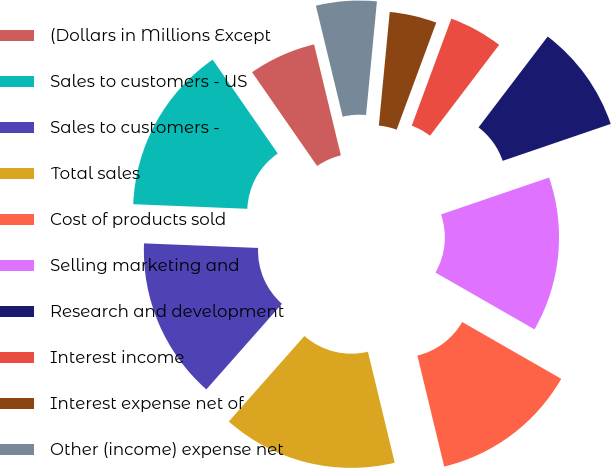<chart> <loc_0><loc_0><loc_500><loc_500><pie_chart><fcel>(Dollars in Millions Except<fcel>Sales to customers - US<fcel>Sales to customers -<fcel>Total sales<fcel>Cost of products sold<fcel>Selling marketing and<fcel>Research and development<fcel>Interest income<fcel>Interest expense net of<fcel>Other (income) expense net<nl><fcel>5.88%<fcel>14.71%<fcel>14.12%<fcel>15.29%<fcel>12.94%<fcel>13.53%<fcel>9.41%<fcel>4.71%<fcel>4.12%<fcel>5.29%<nl></chart> 